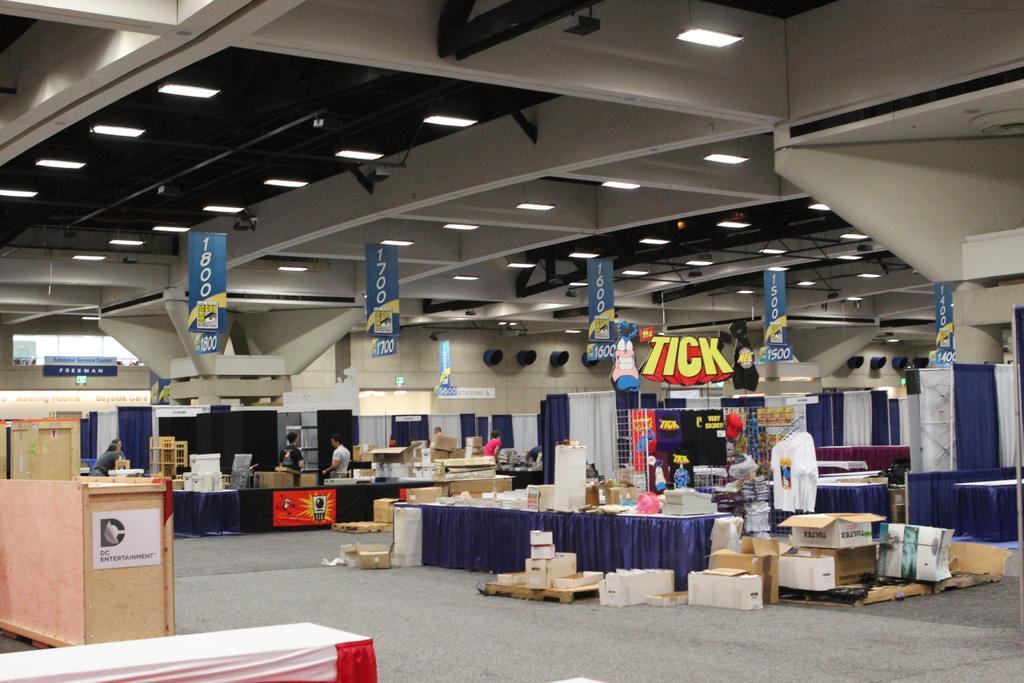Can you describe this image briefly? This picture is an inside view of a room. In the center of the image we can see the tables. On the tables we can see some objects, boxes, boards, cloth. In the background of the image we can see wall, boards, some persons, boxes, curtains. At the bottom of the image there is a floor. On the left side of the image we can see benches. At the top of the image we can see lights, roof. 